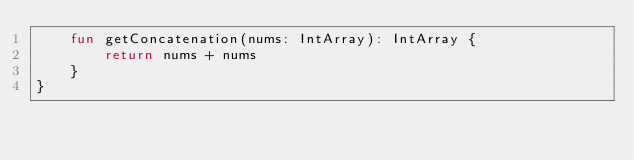<code> <loc_0><loc_0><loc_500><loc_500><_Kotlin_>    fun getConcatenation(nums: IntArray): IntArray {
        return nums + nums
    }
}</code> 